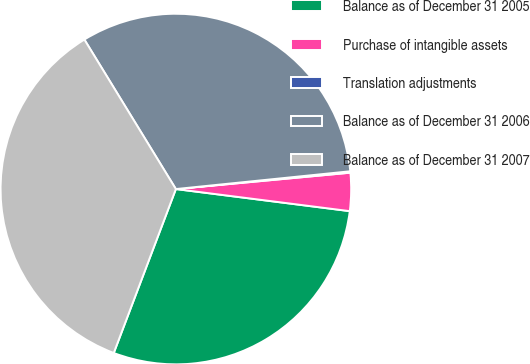<chart> <loc_0><loc_0><loc_500><loc_500><pie_chart><fcel>Balance as of December 31 2005<fcel>Purchase of intangible assets<fcel>Translation adjustments<fcel>Balance as of December 31 2006<fcel>Balance as of December 31 2007<nl><fcel>28.75%<fcel>3.5%<fcel>0.13%<fcel>32.12%<fcel>35.49%<nl></chart> 